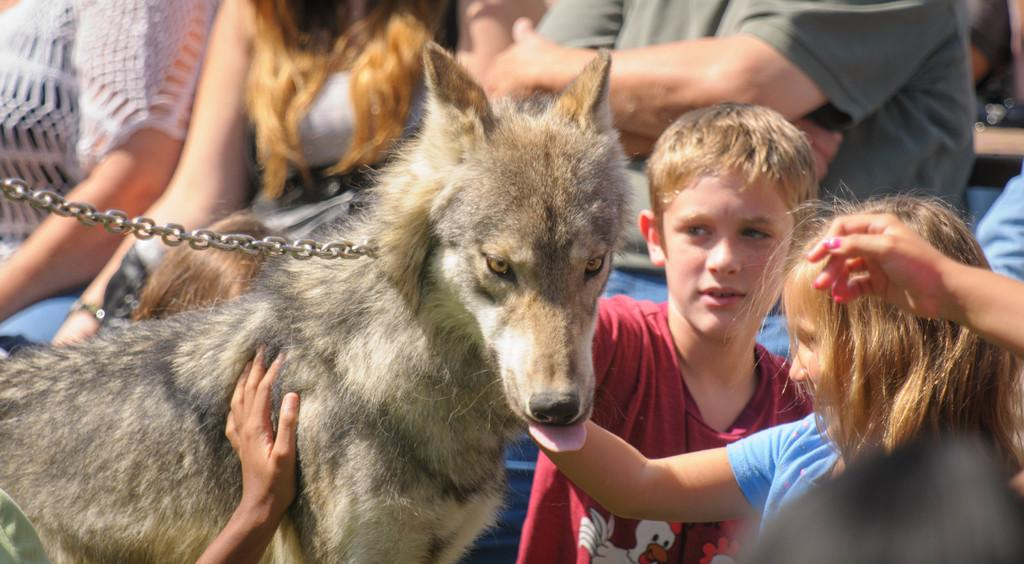What type of animal is present in the image? There is a dog in the image. How are the kids interacting with the dog? The two kids are holding the dog in the image. What can be seen in the background of the image? There is a group of people sitting on chairs in the background of the image. What is the business rate of the drain in the image? There is no drain present in the image, and therefore no business rate can be determined. 